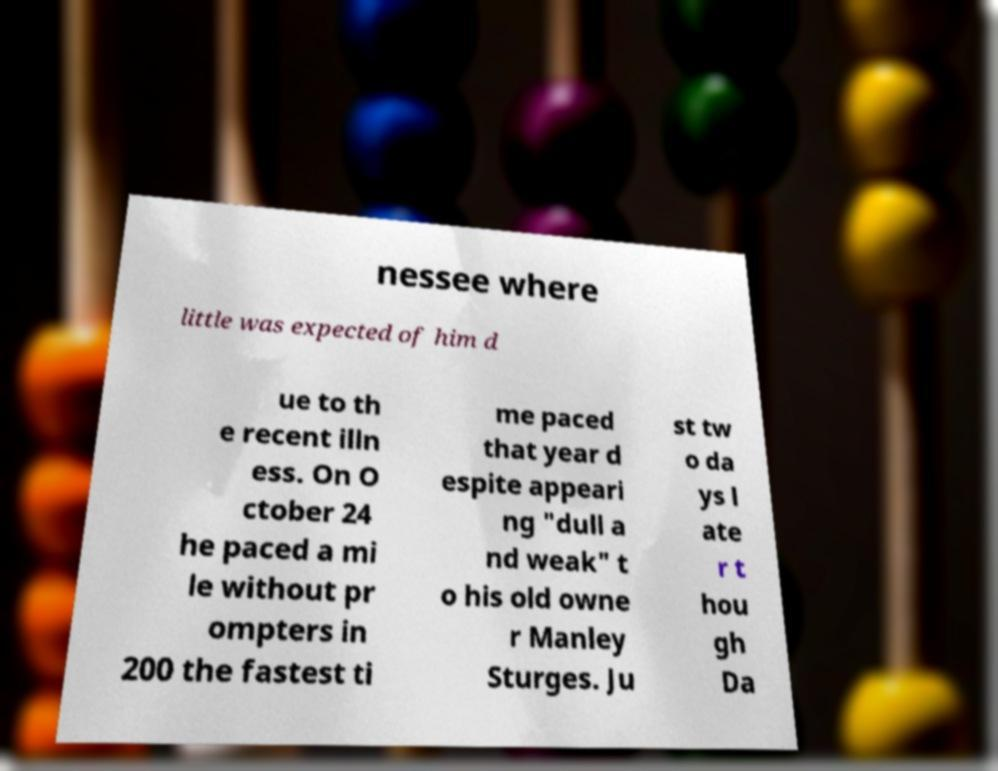Please identify and transcribe the text found in this image. nessee where little was expected of him d ue to th e recent illn ess. On O ctober 24 he paced a mi le without pr ompters in 200 the fastest ti me paced that year d espite appeari ng "dull a nd weak" t o his old owne r Manley Sturges. Ju st tw o da ys l ate r t hou gh Da 